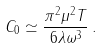Convert formula to latex. <formula><loc_0><loc_0><loc_500><loc_500>C _ { 0 } \simeq \frac { \pi ^ { 2 } \mu ^ { 2 } T } { 6 \lambda \omega ^ { 3 } } \, .</formula> 